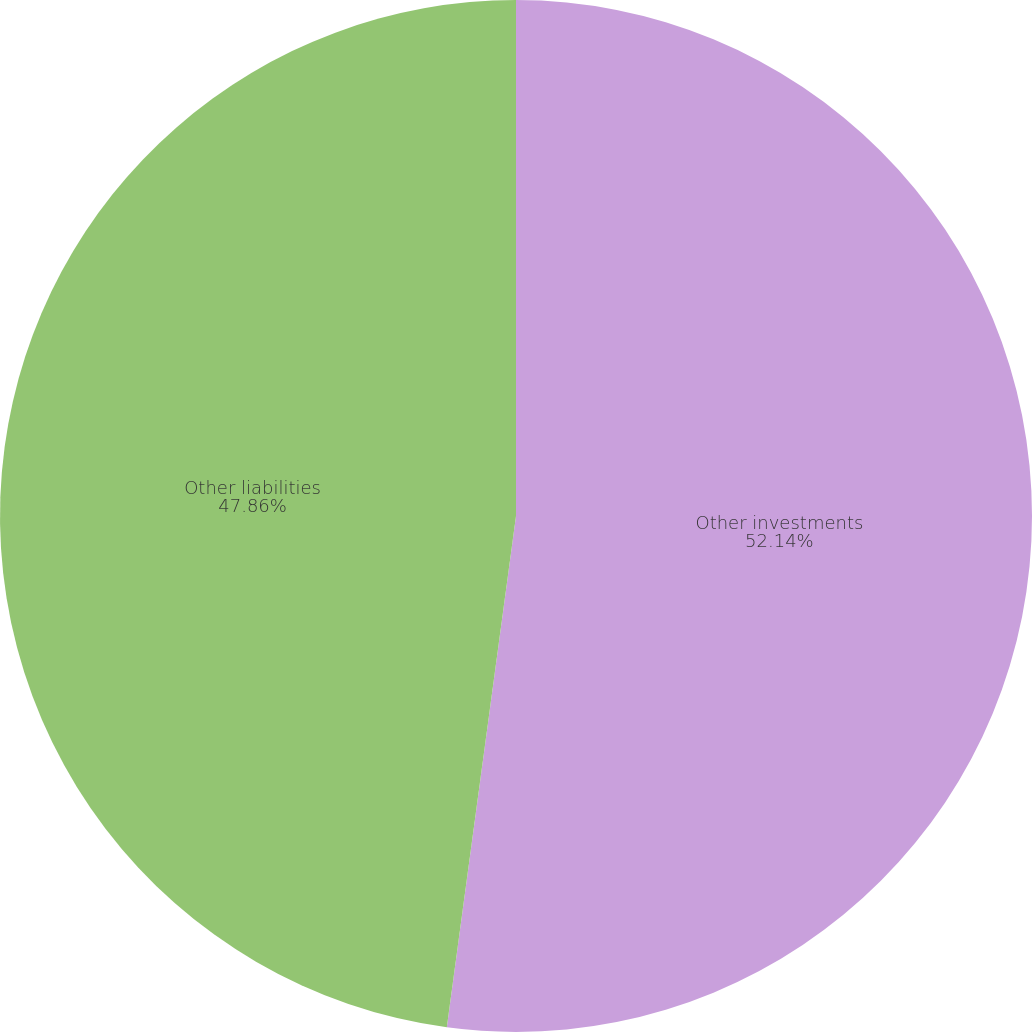Convert chart. <chart><loc_0><loc_0><loc_500><loc_500><pie_chart><fcel>Other investments<fcel>Other liabilities<nl><fcel>52.14%<fcel>47.86%<nl></chart> 